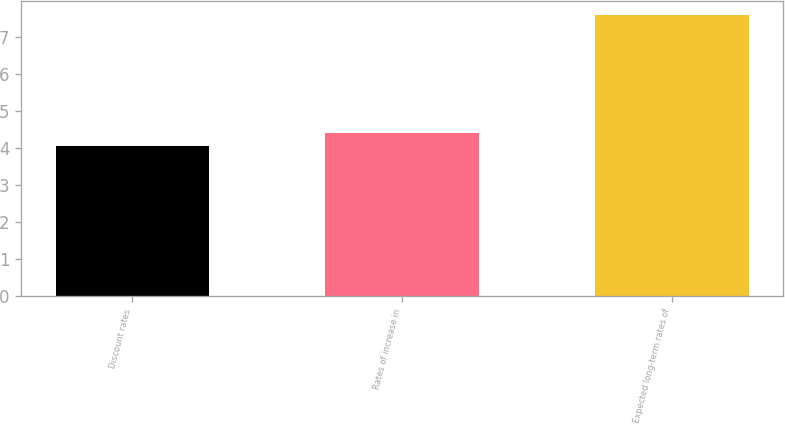Convert chart to OTSL. <chart><loc_0><loc_0><loc_500><loc_500><bar_chart><fcel>Discount rates<fcel>Rates of increase in<fcel>Expected long-term rates of<nl><fcel>4.06<fcel>4.41<fcel>7.58<nl></chart> 